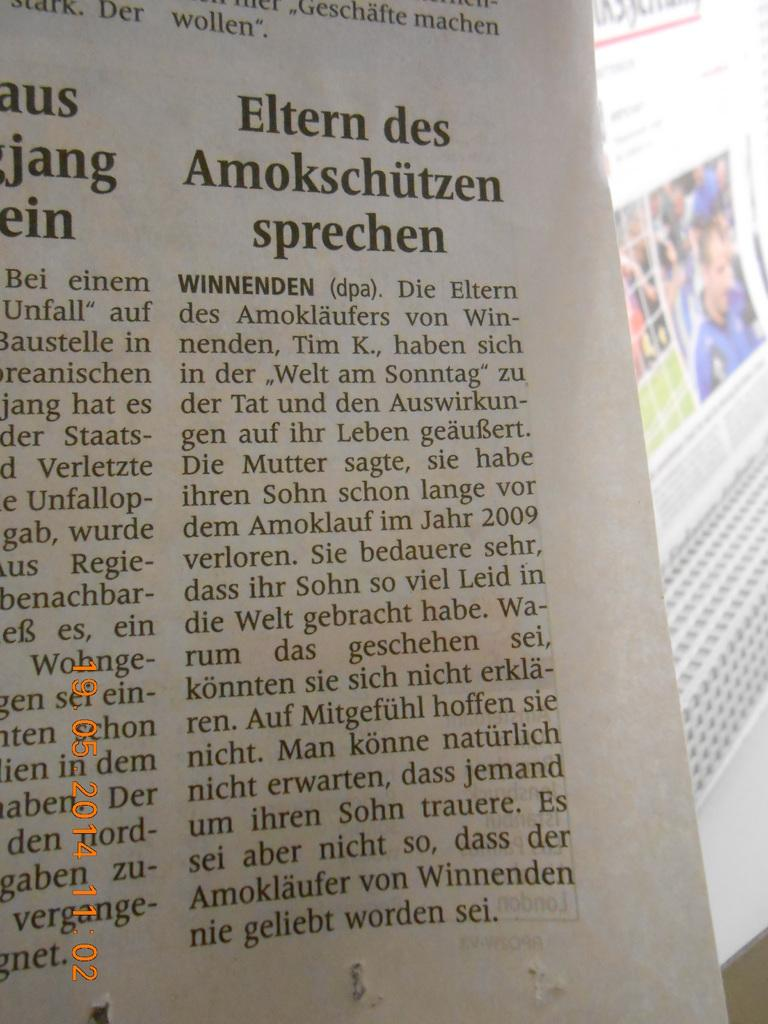<image>
Write a terse but informative summary of the picture. A picture of a newspaper with an article named Eltern des Amokschutzen sprechen shown. 